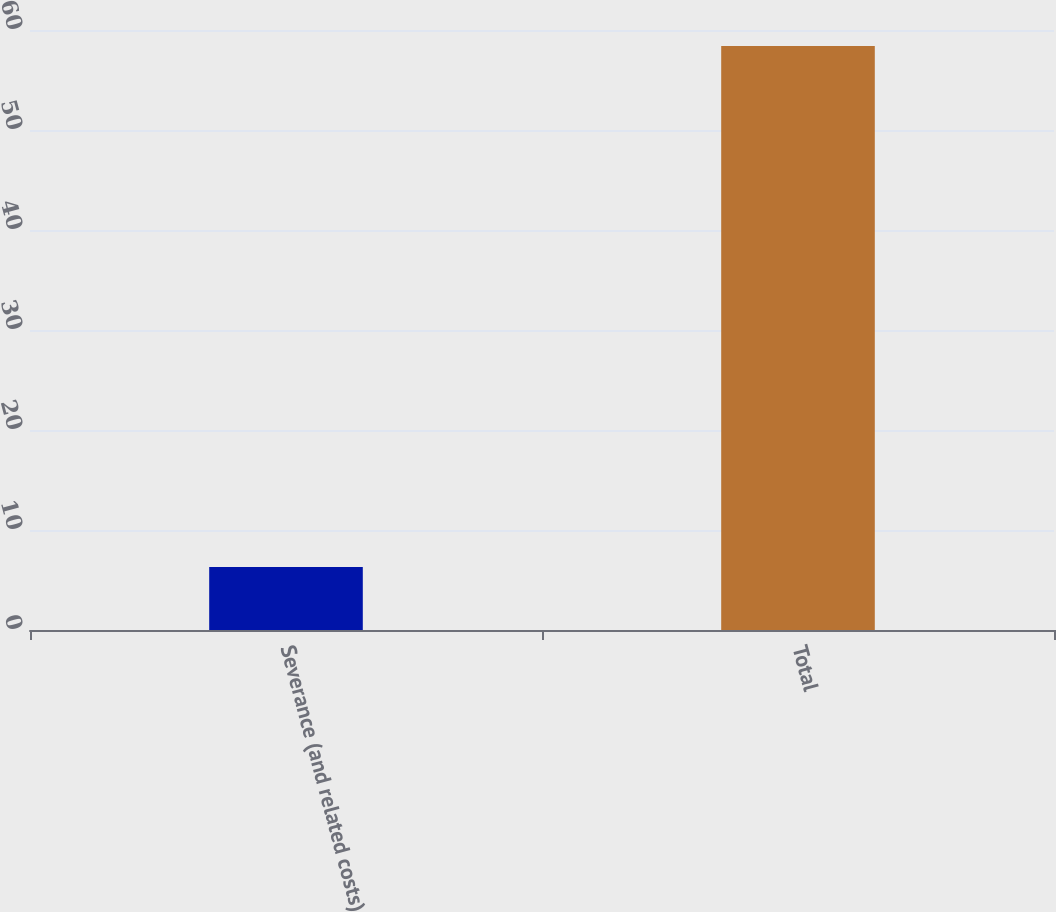Convert chart. <chart><loc_0><loc_0><loc_500><loc_500><bar_chart><fcel>Severance (and related costs)<fcel>Total<nl><fcel>6.3<fcel>58.4<nl></chart> 